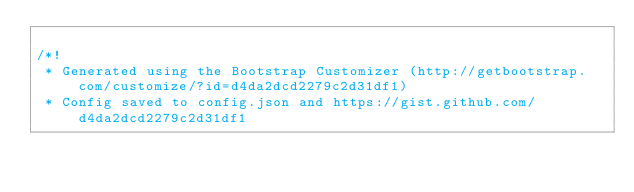Convert code to text. <code><loc_0><loc_0><loc_500><loc_500><_CSS_>
/*!
 * Generated using the Bootstrap Customizer (http://getbootstrap.com/customize/?id=d4da2dcd2279c2d31df1)
 * Config saved to config.json and https://gist.github.com/d4da2dcd2279c2d31df1</code> 